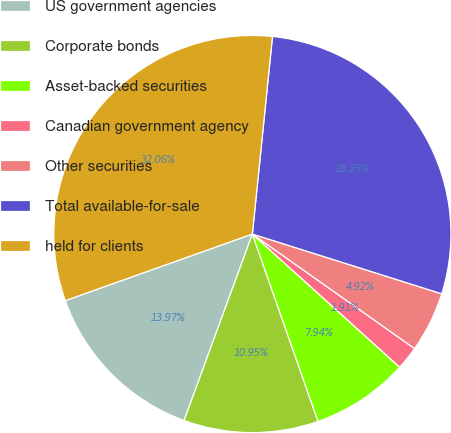Convert chart to OTSL. <chart><loc_0><loc_0><loc_500><loc_500><pie_chart><fcel>US government agencies<fcel>Corporate bonds<fcel>Asset-backed securities<fcel>Canadian government agency<fcel>Other securities<fcel>Total available-for-sale<fcel>held for clients<nl><fcel>13.97%<fcel>10.95%<fcel>7.94%<fcel>1.91%<fcel>4.92%<fcel>28.25%<fcel>32.06%<nl></chart> 